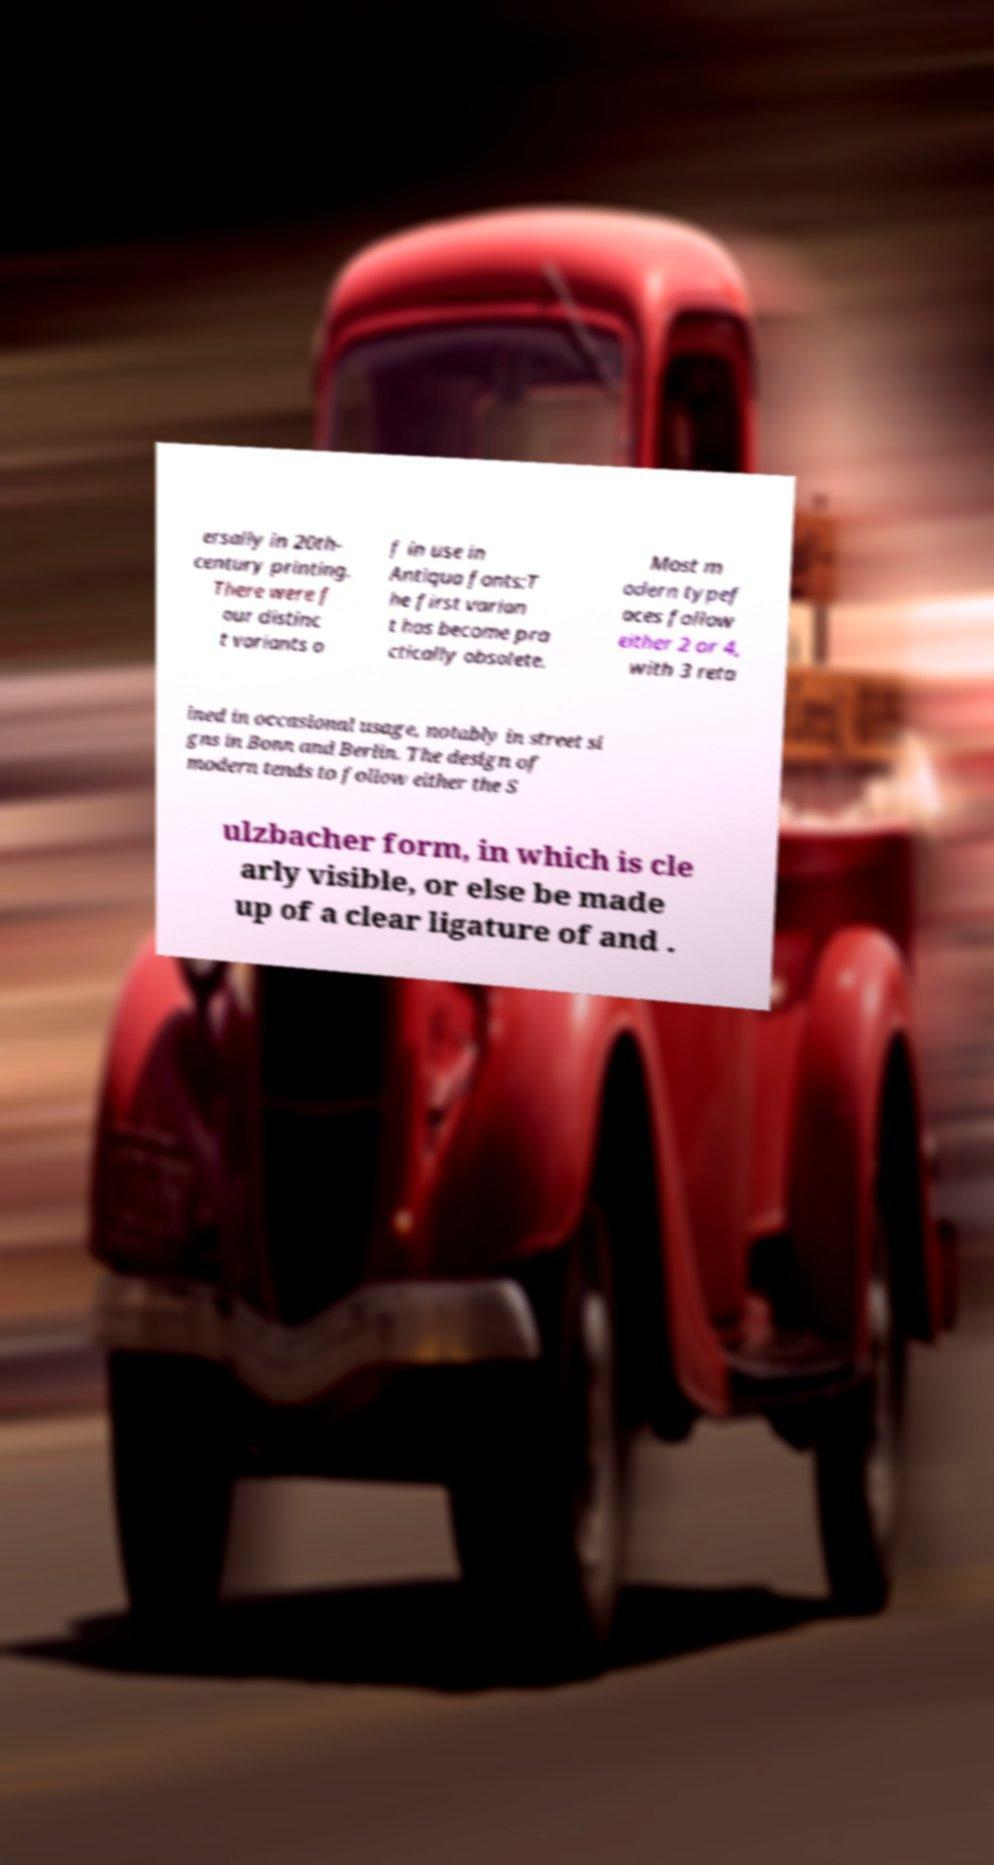Can you read and provide the text displayed in the image?This photo seems to have some interesting text. Can you extract and type it out for me? ersally in 20th- century printing. There were f our distinc t variants o f in use in Antiqua fonts:T he first varian t has become pra ctically obsolete. Most m odern typef aces follow either 2 or 4, with 3 reta ined in occasional usage, notably in street si gns in Bonn and Berlin. The design of modern tends to follow either the S ulzbacher form, in which is cle arly visible, or else be made up of a clear ligature of and . 